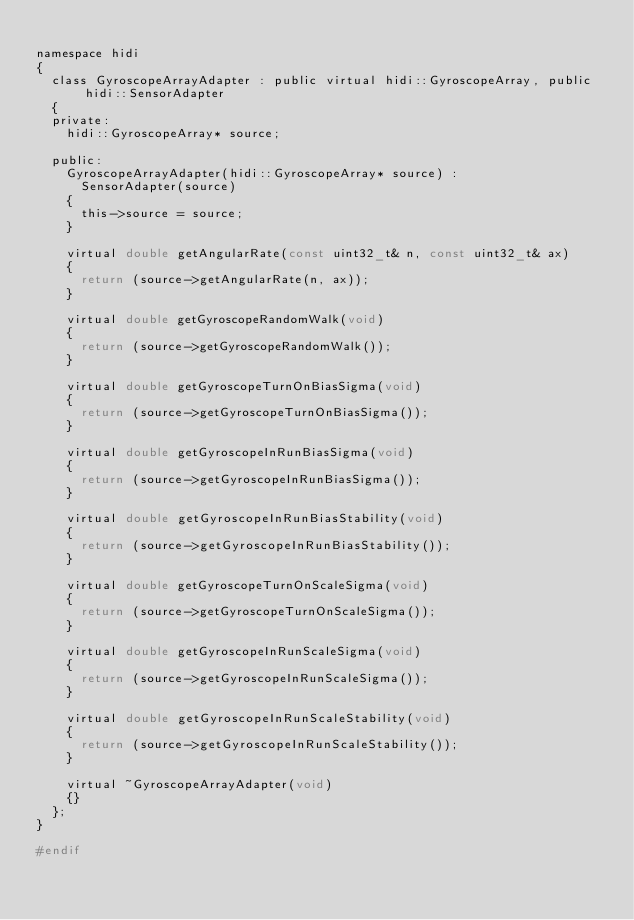Convert code to text. <code><loc_0><loc_0><loc_500><loc_500><_C_>
namespace hidi
{
  class GyroscopeArrayAdapter : public virtual hidi::GyroscopeArray, public hidi::SensorAdapter
  {
  private:
    hidi::GyroscopeArray* source;

  public:
    GyroscopeArrayAdapter(hidi::GyroscopeArray* source) :
      SensorAdapter(source)
    {
      this->source = source;
    }

    virtual double getAngularRate(const uint32_t& n, const uint32_t& ax)
    {
      return (source->getAngularRate(n, ax));
    }

    virtual double getGyroscopeRandomWalk(void)
    {
      return (source->getGyroscopeRandomWalk());
    }

    virtual double getGyroscopeTurnOnBiasSigma(void)
    {
      return (source->getGyroscopeTurnOnBiasSigma());
    }

    virtual double getGyroscopeInRunBiasSigma(void)
    {
      return (source->getGyroscopeInRunBiasSigma());
    }

    virtual double getGyroscopeInRunBiasStability(void)
    {
      return (source->getGyroscopeInRunBiasStability());
    }

    virtual double getGyroscopeTurnOnScaleSigma(void)
    {
      return (source->getGyroscopeTurnOnScaleSigma());
    }

    virtual double getGyroscopeInRunScaleSigma(void)
    {
      return (source->getGyroscopeInRunScaleSigma());
    }

    virtual double getGyroscopeInRunScaleStability(void)
    {
      return (source->getGyroscopeInRunScaleStability());
    }
    
    virtual ~GyroscopeArrayAdapter(void)
    {}
  };
}

#endif
</code> 